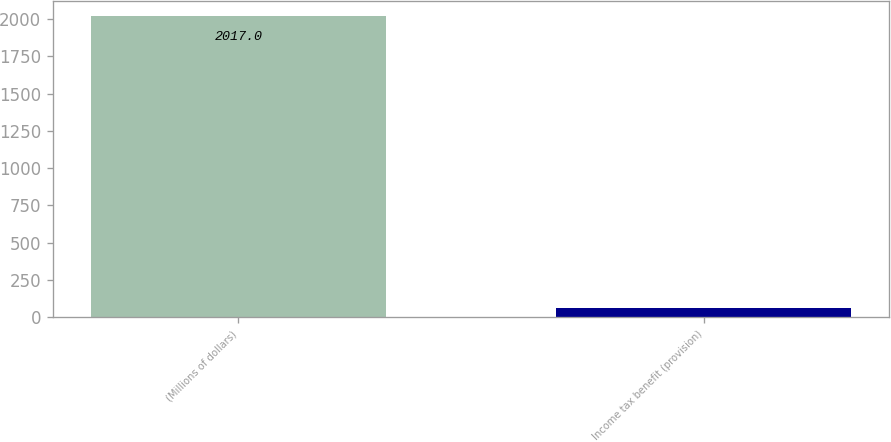Convert chart to OTSL. <chart><loc_0><loc_0><loc_500><loc_500><bar_chart><fcel>(Millions of dollars)<fcel>Income tax benefit (provision)<nl><fcel>2017<fcel>60<nl></chart> 